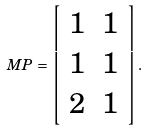Convert formula to latex. <formula><loc_0><loc_0><loc_500><loc_500>M P = \left [ \begin{array} { c c } 1 & 1 \\ 1 & 1 \\ 2 & 1 \end{array} \right ] .</formula> 